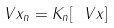<formula> <loc_0><loc_0><loc_500><loc_500>\ V x _ { n } = K _ { n } [ \ V x ]</formula> 